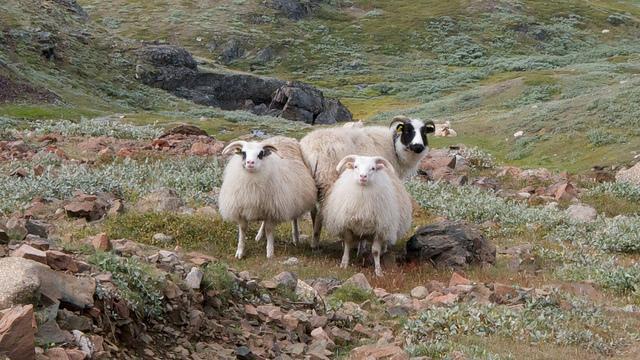What are these animals called?
Select the correct answer and articulate reasoning with the following format: 'Answer: answer
Rationale: rationale.'
Options: Dogs, cows, sheep, deer. Answer: sheep.
Rationale: The animals have horns and wool. they are not cows, deer, or dogs. 